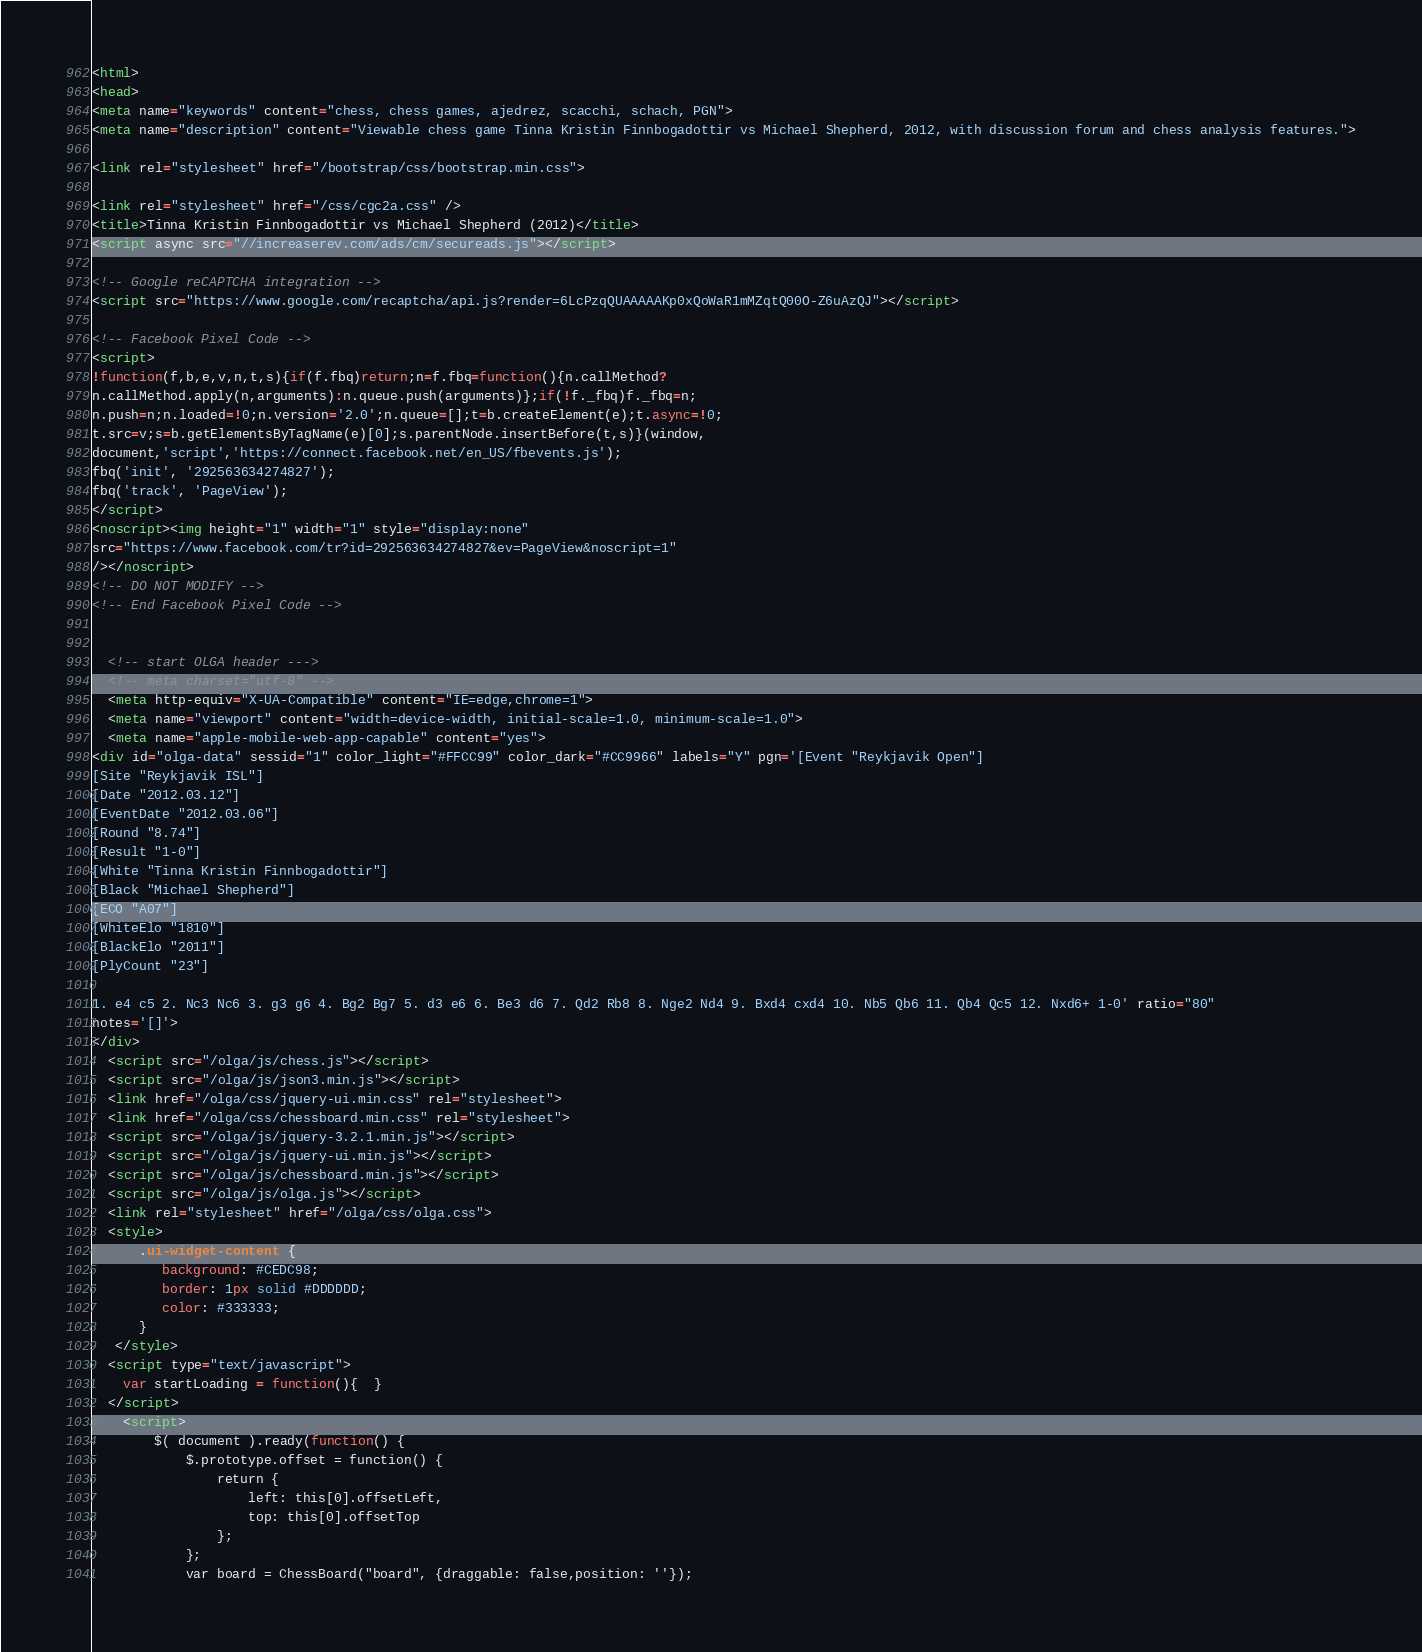<code> <loc_0><loc_0><loc_500><loc_500><_HTML_>
<html>
<head>
<meta name="keywords" content="chess, chess games, ajedrez, scacchi, schach, PGN">
<meta name="description" content="Viewable chess game Tinna Kristin Finnbogadottir vs Michael Shepherd, 2012, with discussion forum and chess analysis features.">

<link rel="stylesheet" href="/bootstrap/css/bootstrap.min.css">

<link rel="stylesheet" href="/css/cgc2a.css" />
<title>Tinna Kristin Finnbogadottir vs Michael Shepherd (2012)</title>
<script async src="//increaserev.com/ads/cm/secureads.js"></script>

<!-- Google reCAPTCHA integration -->
<script src="https://www.google.com/recaptcha/api.js?render=6LcPzqQUAAAAAKp0xQoWaR1mMZqtQ00O-Z6uAzQJ"></script>

<!-- Facebook Pixel Code -->
<script>
!function(f,b,e,v,n,t,s){if(f.fbq)return;n=f.fbq=function(){n.callMethod?
n.callMethod.apply(n,arguments):n.queue.push(arguments)};if(!f._fbq)f._fbq=n;
n.push=n;n.loaded=!0;n.version='2.0';n.queue=[];t=b.createElement(e);t.async=!0;
t.src=v;s=b.getElementsByTagName(e)[0];s.parentNode.insertBefore(t,s)}(window,
document,'script','https://connect.facebook.net/en_US/fbevents.js');
fbq('init', '292563634274827');
fbq('track', 'PageView');
</script>
<noscript><img height="1" width="1" style="display:none"
src="https://www.facebook.com/tr?id=292563634274827&ev=PageView&noscript=1"
/></noscript>
<!-- DO NOT MODIFY -->
<!-- End Facebook Pixel Code -->


  <!-- start OLGA header --->
  <!-- meta charset="utf-8" -->
  <meta http-equiv="X-UA-Compatible" content="IE=edge,chrome=1">
  <meta name="viewport" content="width=device-width, initial-scale=1.0, minimum-scale=1.0">
  <meta name="apple-mobile-web-app-capable" content="yes">
<div id="olga-data" sessid="1" color_light="#FFCC99" color_dark="#CC9966" labels="Y" pgn='[Event "Reykjavik Open"]
[Site "Reykjavik ISL"]
[Date "2012.03.12"]
[EventDate "2012.03.06"]
[Round "8.74"]
[Result "1-0"]
[White "Tinna Kristin Finnbogadottir"]
[Black "Michael Shepherd"]
[ECO "A07"]
[WhiteElo "1810"]
[BlackElo "2011"]
[PlyCount "23"]

1. e4 c5 2. Nc3 Nc6 3. g3 g6 4. Bg2 Bg7 5. d3 e6 6. Be3 d6 7. Qd2 Rb8 8. Nge2 Nd4 9. Bxd4 cxd4 10. Nb5 Qb6 11. Qb4 Qc5 12. Nxd6+ 1-0' ratio="80" 
notes='[]'>
</div>
  <script src="/olga/js/chess.js"></script>
  <script src="/olga/js/json3.min.js"></script>
  <link href="/olga/css/jquery-ui.min.css" rel="stylesheet">
  <link href="/olga/css/chessboard.min.css" rel="stylesheet">
  <script src="/olga/js/jquery-3.2.1.min.js"></script>
  <script src="/olga/js/jquery-ui.min.js"></script>
  <script src="/olga/js/chessboard.min.js"></script>
  <script src="/olga/js/olga.js"></script>
  <link rel="stylesheet" href="/olga/css/olga.css">
  <style>
      .ui-widget-content {
         background: #CEDC98;
         border: 1px solid #DDDDDD;
         color: #333333;
      }
   </style>
  <script type="text/javascript">
    var startLoading = function(){  }
  </script>
	<script>
		$( document ).ready(function() {
			$.prototype.offset = function() {
				return {
					left: this[0].offsetLeft,
					top: this[0].offsetTop
				};
			};
			var board = ChessBoard("board", {draggable: false,position: ''});</code> 